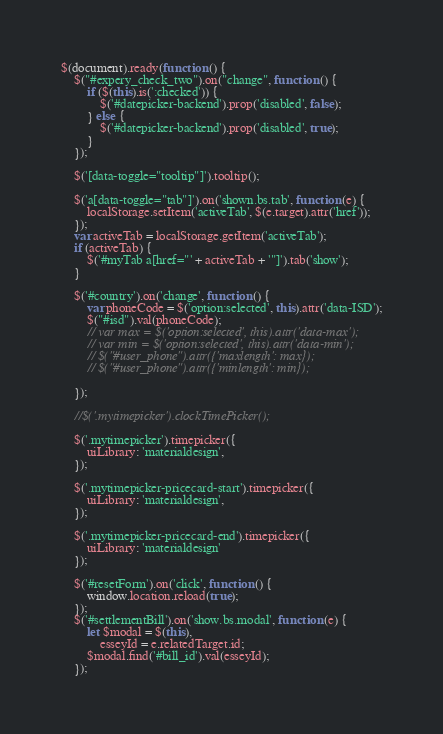<code> <loc_0><loc_0><loc_500><loc_500><_JavaScript_>$(document).ready(function () {
    $("#expery_check_two").on("change", function () {
        if ($(this).is(':checked')) {
            $('#datepicker-backend').prop('disabled', false);
        } else {
            $('#datepicker-backend').prop('disabled', true);
        }
    });

    $('[data-toggle="tooltip"]').tooltip();

    $('a[data-toggle="tab"]').on('shown.bs.tab', function (e) {
        localStorage.setItem('activeTab', $(e.target).attr('href'));
    });
    var activeTab = localStorage.getItem('activeTab');
    if (activeTab) {
        $('#myTab a[href="' + activeTab + '"]').tab('show');
    }

    $('#country').on('change', function () {
        var phoneCode = $('option:selected', this).attr('data-ISD');
        $("#isd").val(phoneCode);
        // var max = $('option:selected', this).attr('data-max');
        // var min = $('option:selected', this).attr('data-min');
        // $("#user_phone").attr({'maxlength': max});
        // $("#user_phone").attr({'minlength': min});

    });

    //$('.mytimepicker').clockTimePicker();

    $('.mytimepicker').timepicker({
        uiLibrary: 'materialdesign',
    });

    $('.mytimepicker-pricecard-start').timepicker({
        uiLibrary: 'materialdesign',
    });

    $('.mytimepicker-pricecard-end').timepicker({
        uiLibrary: 'materialdesign'
    });

    $('#resetForm').on('click', function () {
        window.location.reload(true);
    });
    $('#settlementBill').on('show.bs.modal', function (e) {
        let $modal = $(this),
            esseyId = e.relatedTarget.id;
        $modal.find('#bill_id').val(esseyId);
    });</code> 